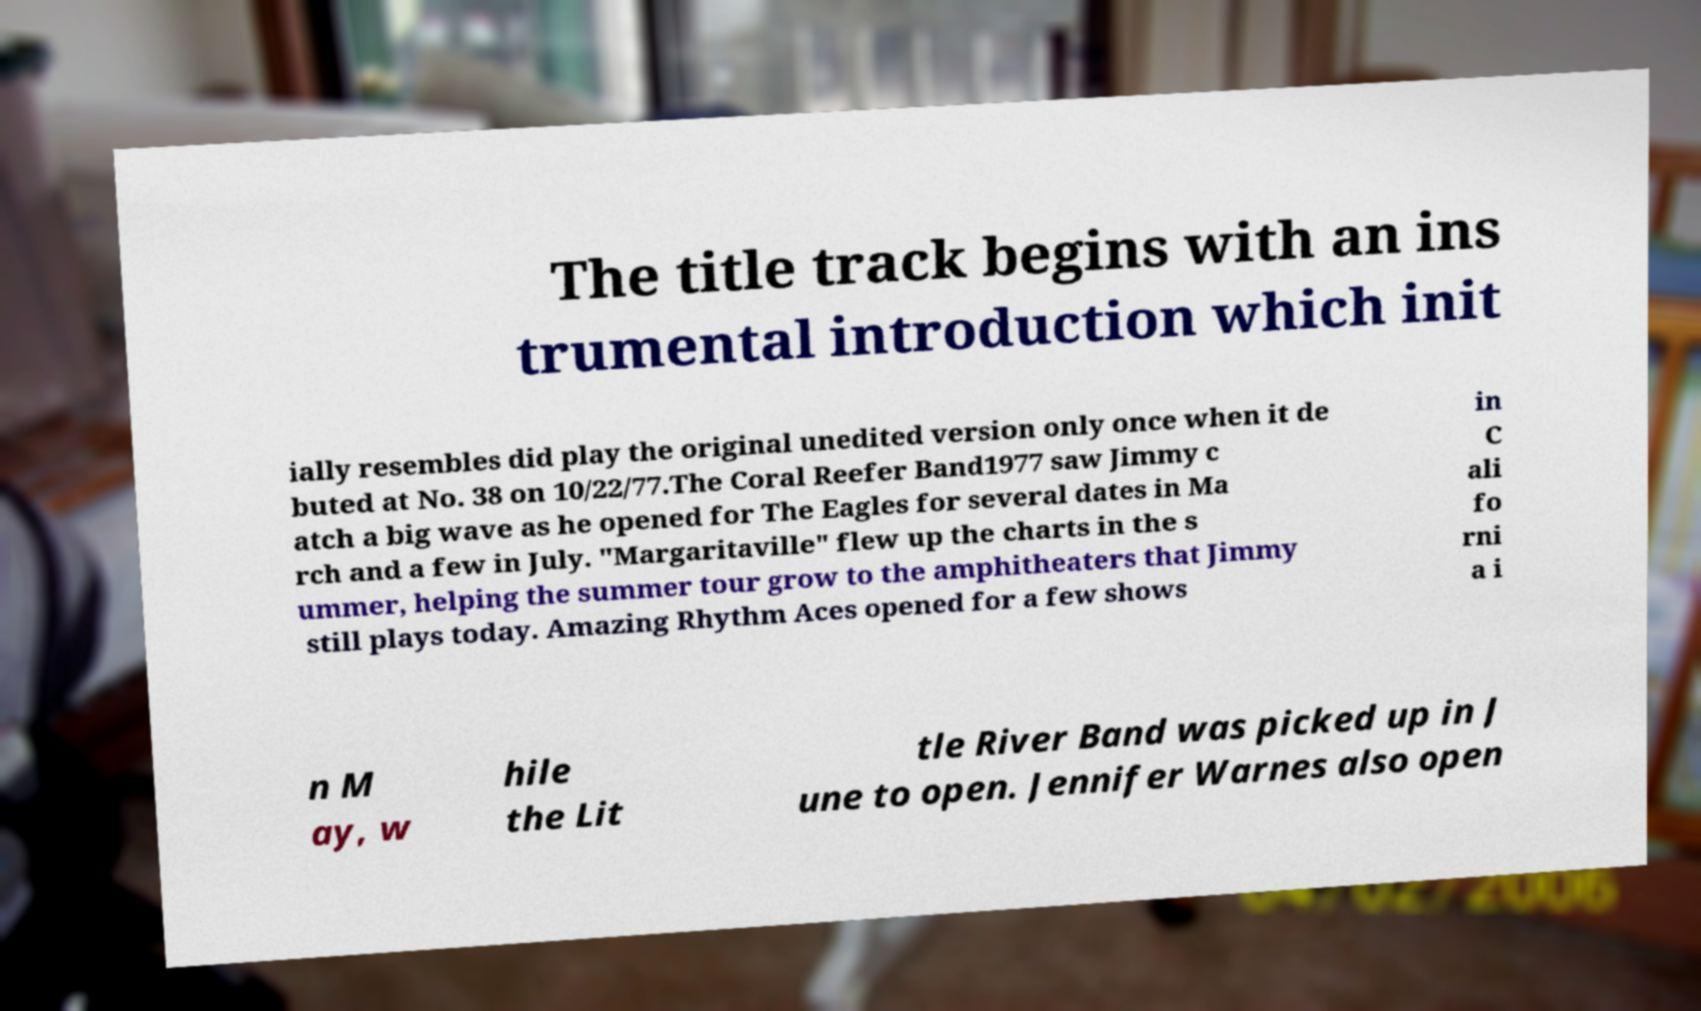Can you read and provide the text displayed in the image?This photo seems to have some interesting text. Can you extract and type it out for me? The title track begins with an ins trumental introduction which init ially resembles did play the original unedited version only once when it de buted at No. 38 on 10/22/77.The Coral Reefer Band1977 saw Jimmy c atch a big wave as he opened for The Eagles for several dates in Ma rch and a few in July. "Margaritaville" flew up the charts in the s ummer, helping the summer tour grow to the amphitheaters that Jimmy still plays today. Amazing Rhythm Aces opened for a few shows in C ali fo rni a i n M ay, w hile the Lit tle River Band was picked up in J une to open. Jennifer Warnes also open 